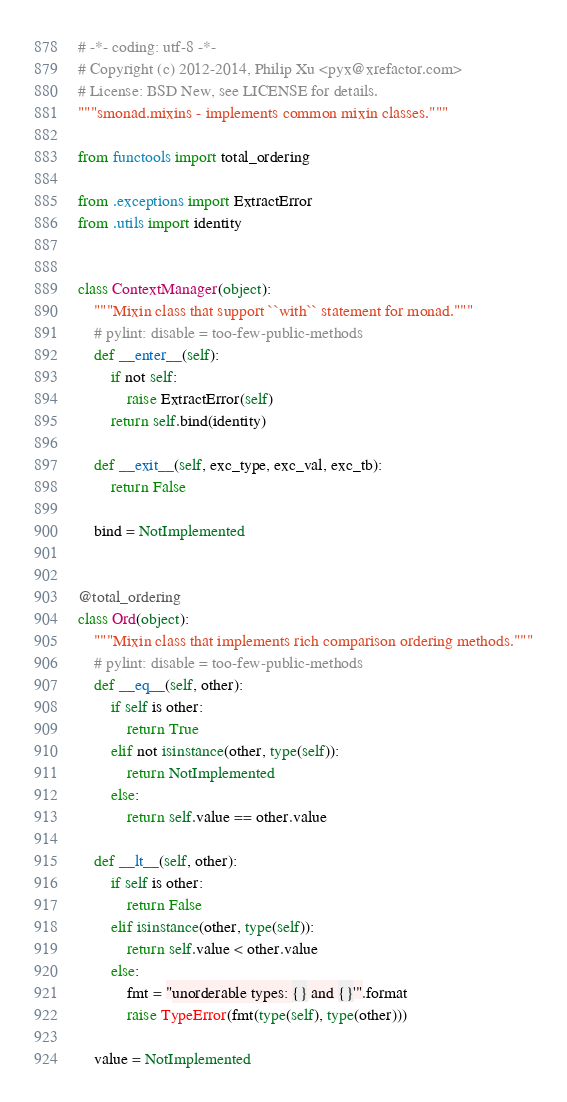<code> <loc_0><loc_0><loc_500><loc_500><_Python_># -*- coding: utf-8 -*-
# Copyright (c) 2012-2014, Philip Xu <pyx@xrefactor.com>
# License: BSD New, see LICENSE for details.
"""smonad.mixins - implements common mixin classes."""

from functools import total_ordering

from .exceptions import ExtractError
from .utils import identity


class ContextManager(object):
    """Mixin class that support ``with`` statement for monad."""
    # pylint: disable = too-few-public-methods
    def __enter__(self):
        if not self:
            raise ExtractError(self)
        return self.bind(identity)

    def __exit__(self, exc_type, exc_val, exc_tb):
        return False

    bind = NotImplemented


@total_ordering
class Ord(object):
    """Mixin class that implements rich comparison ordering methods."""
    # pylint: disable = too-few-public-methods
    def __eq__(self, other):
        if self is other:
            return True
        elif not isinstance(other, type(self)):
            return NotImplemented
        else:
            return self.value == other.value

    def __lt__(self, other):
        if self is other:
            return False
        elif isinstance(other, type(self)):
            return self.value < other.value
        else:
            fmt = "unorderable types: {} and {}'".format
            raise TypeError(fmt(type(self), type(other)))

    value = NotImplemented
</code> 